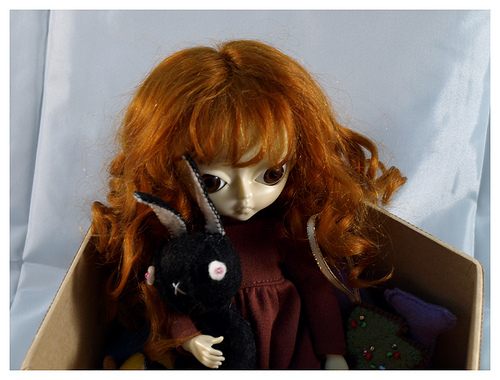<image>
Can you confirm if the wall is behind the doll? Yes. From this viewpoint, the wall is positioned behind the doll, with the doll partially or fully occluding the wall. 